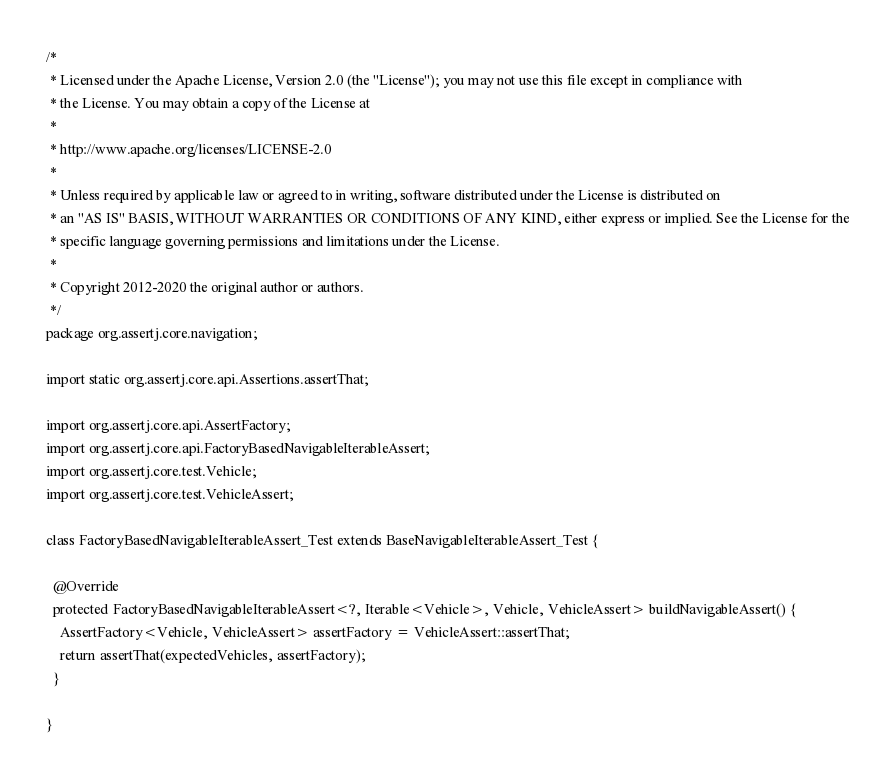Convert code to text. <code><loc_0><loc_0><loc_500><loc_500><_Java_>/*
 * Licensed under the Apache License, Version 2.0 (the "License"); you may not use this file except in compliance with
 * the License. You may obtain a copy of the License at
 *
 * http://www.apache.org/licenses/LICENSE-2.0
 *
 * Unless required by applicable law or agreed to in writing, software distributed under the License is distributed on
 * an "AS IS" BASIS, WITHOUT WARRANTIES OR CONDITIONS OF ANY KIND, either express or implied. See the License for the
 * specific language governing permissions and limitations under the License.
 *
 * Copyright 2012-2020 the original author or authors.
 */
package org.assertj.core.navigation;

import static org.assertj.core.api.Assertions.assertThat;

import org.assertj.core.api.AssertFactory;
import org.assertj.core.api.FactoryBasedNavigableIterableAssert;
import org.assertj.core.test.Vehicle;
import org.assertj.core.test.VehicleAssert;

class FactoryBasedNavigableIterableAssert_Test extends BaseNavigableIterableAssert_Test {

  @Override
  protected FactoryBasedNavigableIterableAssert<?, Iterable<Vehicle>, Vehicle, VehicleAssert> buildNavigableAssert() {
    AssertFactory<Vehicle, VehicleAssert> assertFactory = VehicleAssert::assertThat;
    return assertThat(expectedVehicles, assertFactory);
  }
  
}
</code> 